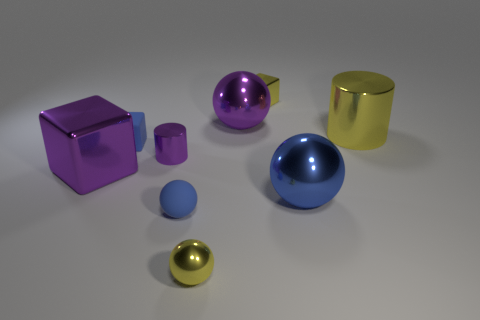Are the purple cylinder and the small blue cube made of the same material?
Provide a succinct answer. No. Are there the same number of large purple metal spheres on the left side of the purple metallic cylinder and small metal balls behind the small blue matte ball?
Give a very brief answer. Yes. Is there a shiny cube behind the large purple thing that is right of the large purple object that is in front of the small cylinder?
Your answer should be very brief. Yes. Does the yellow cylinder have the same size as the purple block?
Provide a succinct answer. Yes. What color is the large metal object in front of the big thing on the left side of the sphere that is left of the small metal sphere?
Provide a succinct answer. Blue. How many tiny metallic balls have the same color as the rubber ball?
Give a very brief answer. 0. What number of large things are either purple metal things or blue rubber spheres?
Ensure brevity in your answer.  2. Is there another tiny shiny thing that has the same shape as the blue metallic thing?
Your answer should be very brief. Yes. Is the small purple thing the same shape as the blue metal object?
Offer a terse response. No. The large thing to the left of the yellow shiny object that is in front of the purple cube is what color?
Offer a very short reply. Purple. 